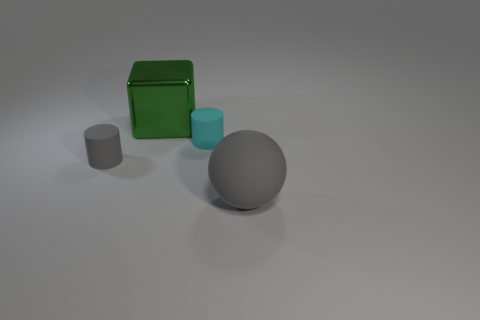Is the number of cyan matte objects to the left of the green thing less than the number of large gray things? yes 